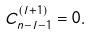Convert formula to latex. <formula><loc_0><loc_0><loc_500><loc_500>C ^ { ( l + 1 ) } _ { n - l - 1 } = 0 .</formula> 